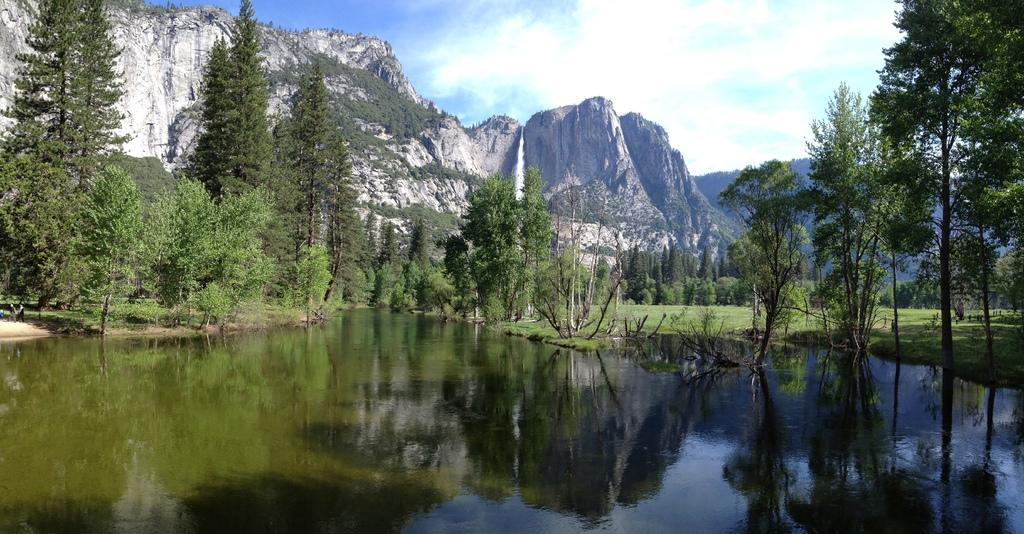What type of vegetation can be seen in the image? There are trees and plants in the image. What type of terrain is visible in the image? There are hills in the image. What is the ground covered with in the image? There is grass visible in the image. What is visible in the sky in the image? The sky is visible in the image, and there are clouds in the sky. What body of water is present in the image? There is water in the image. What can be seen reflected in the water? The water has a reflection of trees and hills. Where is the lamp located in the image? There is no lamp present in the image. Can you provide an example of a tree in the image? There is no need to provide an example of a tree, as the image already contains trees. 